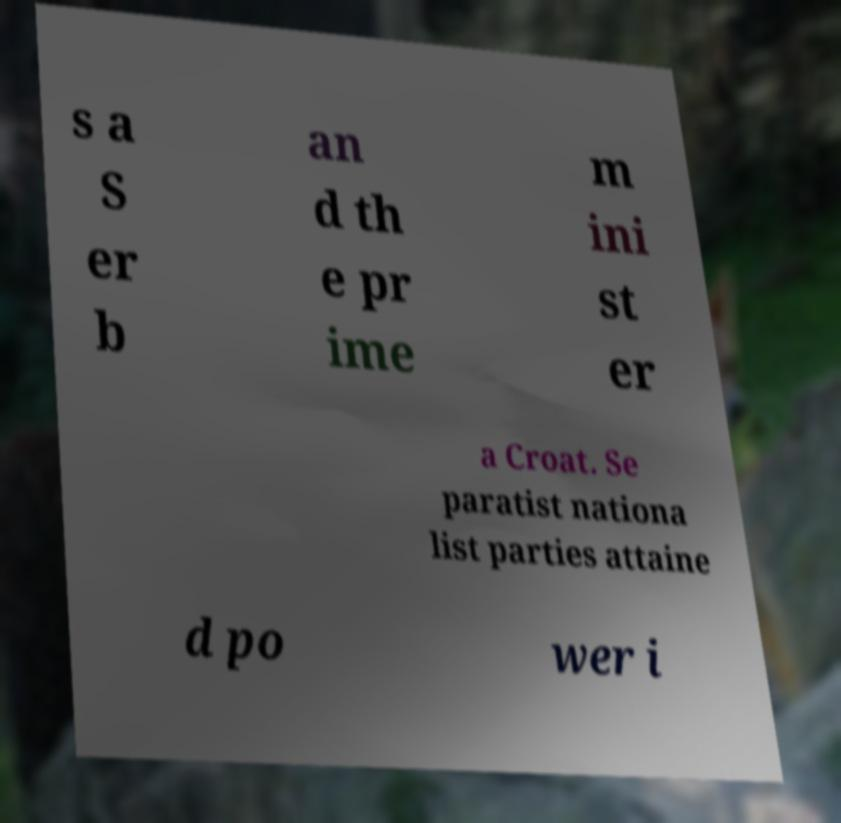Can you accurately transcribe the text from the provided image for me? s a S er b an d th e pr ime m ini st er a Croat. Se paratist nationa list parties attaine d po wer i 